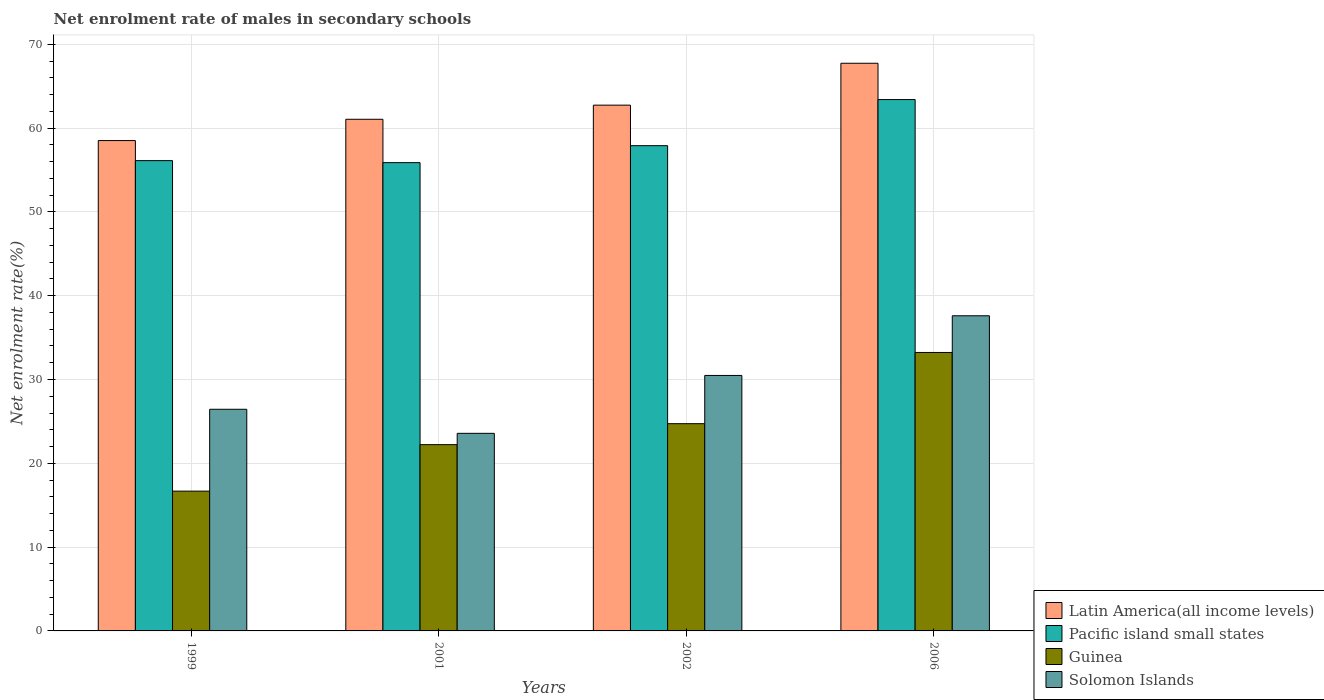How many groups of bars are there?
Offer a very short reply. 4. Are the number of bars on each tick of the X-axis equal?
Your answer should be very brief. Yes. How many bars are there on the 1st tick from the left?
Offer a terse response. 4. What is the label of the 4th group of bars from the left?
Ensure brevity in your answer.  2006. What is the net enrolment rate of males in secondary schools in Guinea in 1999?
Your answer should be very brief. 16.68. Across all years, what is the maximum net enrolment rate of males in secondary schools in Solomon Islands?
Offer a terse response. 37.61. Across all years, what is the minimum net enrolment rate of males in secondary schools in Pacific island small states?
Your response must be concise. 55.88. In which year was the net enrolment rate of males in secondary schools in Latin America(all income levels) maximum?
Your answer should be compact. 2006. In which year was the net enrolment rate of males in secondary schools in Pacific island small states minimum?
Make the answer very short. 2001. What is the total net enrolment rate of males in secondary schools in Solomon Islands in the graph?
Offer a very short reply. 118.12. What is the difference between the net enrolment rate of males in secondary schools in Pacific island small states in 2001 and that in 2002?
Offer a very short reply. -2.03. What is the difference between the net enrolment rate of males in secondary schools in Solomon Islands in 2006 and the net enrolment rate of males in secondary schools in Pacific island small states in 1999?
Provide a succinct answer. -18.51. What is the average net enrolment rate of males in secondary schools in Pacific island small states per year?
Your answer should be very brief. 58.33. In the year 2002, what is the difference between the net enrolment rate of males in secondary schools in Pacific island small states and net enrolment rate of males in secondary schools in Latin America(all income levels)?
Your response must be concise. -4.84. In how many years, is the net enrolment rate of males in secondary schools in Guinea greater than 38 %?
Provide a succinct answer. 0. What is the ratio of the net enrolment rate of males in secondary schools in Solomon Islands in 1999 to that in 2006?
Your response must be concise. 0.7. Is the difference between the net enrolment rate of males in secondary schools in Pacific island small states in 2001 and 2002 greater than the difference between the net enrolment rate of males in secondary schools in Latin America(all income levels) in 2001 and 2002?
Your response must be concise. No. What is the difference between the highest and the second highest net enrolment rate of males in secondary schools in Guinea?
Provide a short and direct response. 8.5. What is the difference between the highest and the lowest net enrolment rate of males in secondary schools in Pacific island small states?
Your answer should be very brief. 7.53. In how many years, is the net enrolment rate of males in secondary schools in Latin America(all income levels) greater than the average net enrolment rate of males in secondary schools in Latin America(all income levels) taken over all years?
Your answer should be very brief. 2. Is the sum of the net enrolment rate of males in secondary schools in Pacific island small states in 2002 and 2006 greater than the maximum net enrolment rate of males in secondary schools in Solomon Islands across all years?
Give a very brief answer. Yes. Is it the case that in every year, the sum of the net enrolment rate of males in secondary schools in Solomon Islands and net enrolment rate of males in secondary schools in Guinea is greater than the sum of net enrolment rate of males in secondary schools in Pacific island small states and net enrolment rate of males in secondary schools in Latin America(all income levels)?
Provide a short and direct response. No. What does the 4th bar from the left in 2001 represents?
Your answer should be very brief. Solomon Islands. What does the 2nd bar from the right in 2001 represents?
Provide a short and direct response. Guinea. How many bars are there?
Your response must be concise. 16. How many legend labels are there?
Offer a very short reply. 4. What is the title of the graph?
Make the answer very short. Net enrolment rate of males in secondary schools. What is the label or title of the X-axis?
Give a very brief answer. Years. What is the label or title of the Y-axis?
Your answer should be compact. Net enrolment rate(%). What is the Net enrolment rate(%) of Latin America(all income levels) in 1999?
Provide a succinct answer. 58.51. What is the Net enrolment rate(%) of Pacific island small states in 1999?
Ensure brevity in your answer.  56.12. What is the Net enrolment rate(%) in Guinea in 1999?
Offer a terse response. 16.68. What is the Net enrolment rate(%) in Solomon Islands in 1999?
Offer a very short reply. 26.45. What is the Net enrolment rate(%) of Latin America(all income levels) in 2001?
Provide a short and direct response. 61.05. What is the Net enrolment rate(%) in Pacific island small states in 2001?
Your answer should be compact. 55.88. What is the Net enrolment rate(%) in Guinea in 2001?
Make the answer very short. 22.23. What is the Net enrolment rate(%) in Solomon Islands in 2001?
Provide a succinct answer. 23.58. What is the Net enrolment rate(%) of Latin America(all income levels) in 2002?
Offer a terse response. 62.74. What is the Net enrolment rate(%) of Pacific island small states in 2002?
Give a very brief answer. 57.9. What is the Net enrolment rate(%) of Guinea in 2002?
Make the answer very short. 24.73. What is the Net enrolment rate(%) of Solomon Islands in 2002?
Provide a short and direct response. 30.48. What is the Net enrolment rate(%) of Latin America(all income levels) in 2006?
Your answer should be very brief. 67.74. What is the Net enrolment rate(%) of Pacific island small states in 2006?
Keep it short and to the point. 63.41. What is the Net enrolment rate(%) in Guinea in 2006?
Keep it short and to the point. 33.23. What is the Net enrolment rate(%) of Solomon Islands in 2006?
Ensure brevity in your answer.  37.61. Across all years, what is the maximum Net enrolment rate(%) of Latin America(all income levels)?
Ensure brevity in your answer.  67.74. Across all years, what is the maximum Net enrolment rate(%) of Pacific island small states?
Your response must be concise. 63.41. Across all years, what is the maximum Net enrolment rate(%) of Guinea?
Make the answer very short. 33.23. Across all years, what is the maximum Net enrolment rate(%) of Solomon Islands?
Make the answer very short. 37.61. Across all years, what is the minimum Net enrolment rate(%) of Latin America(all income levels)?
Ensure brevity in your answer.  58.51. Across all years, what is the minimum Net enrolment rate(%) of Pacific island small states?
Provide a succinct answer. 55.88. Across all years, what is the minimum Net enrolment rate(%) in Guinea?
Your answer should be very brief. 16.68. Across all years, what is the minimum Net enrolment rate(%) of Solomon Islands?
Your answer should be very brief. 23.58. What is the total Net enrolment rate(%) of Latin America(all income levels) in the graph?
Provide a short and direct response. 250.04. What is the total Net enrolment rate(%) of Pacific island small states in the graph?
Offer a very short reply. 233.3. What is the total Net enrolment rate(%) of Guinea in the graph?
Keep it short and to the point. 96.87. What is the total Net enrolment rate(%) of Solomon Islands in the graph?
Offer a very short reply. 118.12. What is the difference between the Net enrolment rate(%) of Latin America(all income levels) in 1999 and that in 2001?
Your answer should be very brief. -2.54. What is the difference between the Net enrolment rate(%) in Pacific island small states in 1999 and that in 2001?
Provide a succinct answer. 0.24. What is the difference between the Net enrolment rate(%) of Guinea in 1999 and that in 2001?
Provide a short and direct response. -5.55. What is the difference between the Net enrolment rate(%) in Solomon Islands in 1999 and that in 2001?
Your answer should be compact. 2.87. What is the difference between the Net enrolment rate(%) of Latin America(all income levels) in 1999 and that in 2002?
Your response must be concise. -4.23. What is the difference between the Net enrolment rate(%) of Pacific island small states in 1999 and that in 2002?
Your answer should be compact. -1.79. What is the difference between the Net enrolment rate(%) in Guinea in 1999 and that in 2002?
Offer a very short reply. -8.05. What is the difference between the Net enrolment rate(%) of Solomon Islands in 1999 and that in 2002?
Make the answer very short. -4.04. What is the difference between the Net enrolment rate(%) in Latin America(all income levels) in 1999 and that in 2006?
Offer a terse response. -9.23. What is the difference between the Net enrolment rate(%) in Pacific island small states in 1999 and that in 2006?
Keep it short and to the point. -7.29. What is the difference between the Net enrolment rate(%) in Guinea in 1999 and that in 2006?
Offer a terse response. -16.55. What is the difference between the Net enrolment rate(%) of Solomon Islands in 1999 and that in 2006?
Keep it short and to the point. -11.16. What is the difference between the Net enrolment rate(%) of Latin America(all income levels) in 2001 and that in 2002?
Ensure brevity in your answer.  -1.69. What is the difference between the Net enrolment rate(%) in Pacific island small states in 2001 and that in 2002?
Make the answer very short. -2.03. What is the difference between the Net enrolment rate(%) of Guinea in 2001 and that in 2002?
Make the answer very short. -2.5. What is the difference between the Net enrolment rate(%) of Solomon Islands in 2001 and that in 2002?
Keep it short and to the point. -6.91. What is the difference between the Net enrolment rate(%) of Latin America(all income levels) in 2001 and that in 2006?
Offer a terse response. -6.68. What is the difference between the Net enrolment rate(%) of Pacific island small states in 2001 and that in 2006?
Ensure brevity in your answer.  -7.53. What is the difference between the Net enrolment rate(%) in Guinea in 2001 and that in 2006?
Make the answer very short. -11. What is the difference between the Net enrolment rate(%) in Solomon Islands in 2001 and that in 2006?
Your answer should be compact. -14.03. What is the difference between the Net enrolment rate(%) of Latin America(all income levels) in 2002 and that in 2006?
Ensure brevity in your answer.  -5. What is the difference between the Net enrolment rate(%) in Pacific island small states in 2002 and that in 2006?
Offer a terse response. -5.5. What is the difference between the Net enrolment rate(%) in Guinea in 2002 and that in 2006?
Provide a short and direct response. -8.5. What is the difference between the Net enrolment rate(%) in Solomon Islands in 2002 and that in 2006?
Your answer should be very brief. -7.12. What is the difference between the Net enrolment rate(%) of Latin America(all income levels) in 1999 and the Net enrolment rate(%) of Pacific island small states in 2001?
Offer a very short reply. 2.63. What is the difference between the Net enrolment rate(%) of Latin America(all income levels) in 1999 and the Net enrolment rate(%) of Guinea in 2001?
Your answer should be very brief. 36.28. What is the difference between the Net enrolment rate(%) in Latin America(all income levels) in 1999 and the Net enrolment rate(%) in Solomon Islands in 2001?
Provide a short and direct response. 34.93. What is the difference between the Net enrolment rate(%) of Pacific island small states in 1999 and the Net enrolment rate(%) of Guinea in 2001?
Provide a succinct answer. 33.89. What is the difference between the Net enrolment rate(%) of Pacific island small states in 1999 and the Net enrolment rate(%) of Solomon Islands in 2001?
Ensure brevity in your answer.  32.54. What is the difference between the Net enrolment rate(%) in Guinea in 1999 and the Net enrolment rate(%) in Solomon Islands in 2001?
Your answer should be compact. -6.9. What is the difference between the Net enrolment rate(%) of Latin America(all income levels) in 1999 and the Net enrolment rate(%) of Pacific island small states in 2002?
Make the answer very short. 0.61. What is the difference between the Net enrolment rate(%) of Latin America(all income levels) in 1999 and the Net enrolment rate(%) of Guinea in 2002?
Your answer should be very brief. 33.78. What is the difference between the Net enrolment rate(%) in Latin America(all income levels) in 1999 and the Net enrolment rate(%) in Solomon Islands in 2002?
Offer a very short reply. 28.03. What is the difference between the Net enrolment rate(%) in Pacific island small states in 1999 and the Net enrolment rate(%) in Guinea in 2002?
Provide a short and direct response. 31.39. What is the difference between the Net enrolment rate(%) of Pacific island small states in 1999 and the Net enrolment rate(%) of Solomon Islands in 2002?
Keep it short and to the point. 25.63. What is the difference between the Net enrolment rate(%) of Guinea in 1999 and the Net enrolment rate(%) of Solomon Islands in 2002?
Provide a succinct answer. -13.8. What is the difference between the Net enrolment rate(%) in Latin America(all income levels) in 1999 and the Net enrolment rate(%) in Pacific island small states in 2006?
Your answer should be very brief. -4.89. What is the difference between the Net enrolment rate(%) of Latin America(all income levels) in 1999 and the Net enrolment rate(%) of Guinea in 2006?
Offer a very short reply. 25.28. What is the difference between the Net enrolment rate(%) of Latin America(all income levels) in 1999 and the Net enrolment rate(%) of Solomon Islands in 2006?
Ensure brevity in your answer.  20.91. What is the difference between the Net enrolment rate(%) of Pacific island small states in 1999 and the Net enrolment rate(%) of Guinea in 2006?
Your answer should be very brief. 22.89. What is the difference between the Net enrolment rate(%) in Pacific island small states in 1999 and the Net enrolment rate(%) in Solomon Islands in 2006?
Give a very brief answer. 18.51. What is the difference between the Net enrolment rate(%) of Guinea in 1999 and the Net enrolment rate(%) of Solomon Islands in 2006?
Offer a very short reply. -20.92. What is the difference between the Net enrolment rate(%) of Latin America(all income levels) in 2001 and the Net enrolment rate(%) of Pacific island small states in 2002?
Keep it short and to the point. 3.15. What is the difference between the Net enrolment rate(%) of Latin America(all income levels) in 2001 and the Net enrolment rate(%) of Guinea in 2002?
Provide a short and direct response. 36.32. What is the difference between the Net enrolment rate(%) of Latin America(all income levels) in 2001 and the Net enrolment rate(%) of Solomon Islands in 2002?
Keep it short and to the point. 30.57. What is the difference between the Net enrolment rate(%) in Pacific island small states in 2001 and the Net enrolment rate(%) in Guinea in 2002?
Provide a succinct answer. 31.15. What is the difference between the Net enrolment rate(%) in Pacific island small states in 2001 and the Net enrolment rate(%) in Solomon Islands in 2002?
Your answer should be very brief. 25.39. What is the difference between the Net enrolment rate(%) of Guinea in 2001 and the Net enrolment rate(%) of Solomon Islands in 2002?
Your answer should be very brief. -8.26. What is the difference between the Net enrolment rate(%) of Latin America(all income levels) in 2001 and the Net enrolment rate(%) of Pacific island small states in 2006?
Offer a terse response. -2.35. What is the difference between the Net enrolment rate(%) of Latin America(all income levels) in 2001 and the Net enrolment rate(%) of Guinea in 2006?
Your answer should be compact. 27.82. What is the difference between the Net enrolment rate(%) of Latin America(all income levels) in 2001 and the Net enrolment rate(%) of Solomon Islands in 2006?
Your answer should be compact. 23.45. What is the difference between the Net enrolment rate(%) of Pacific island small states in 2001 and the Net enrolment rate(%) of Guinea in 2006?
Ensure brevity in your answer.  22.65. What is the difference between the Net enrolment rate(%) in Pacific island small states in 2001 and the Net enrolment rate(%) in Solomon Islands in 2006?
Ensure brevity in your answer.  18.27. What is the difference between the Net enrolment rate(%) in Guinea in 2001 and the Net enrolment rate(%) in Solomon Islands in 2006?
Keep it short and to the point. -15.38. What is the difference between the Net enrolment rate(%) in Latin America(all income levels) in 2002 and the Net enrolment rate(%) in Pacific island small states in 2006?
Keep it short and to the point. -0.67. What is the difference between the Net enrolment rate(%) of Latin America(all income levels) in 2002 and the Net enrolment rate(%) of Guinea in 2006?
Your response must be concise. 29.51. What is the difference between the Net enrolment rate(%) of Latin America(all income levels) in 2002 and the Net enrolment rate(%) of Solomon Islands in 2006?
Your answer should be compact. 25.13. What is the difference between the Net enrolment rate(%) of Pacific island small states in 2002 and the Net enrolment rate(%) of Guinea in 2006?
Ensure brevity in your answer.  24.67. What is the difference between the Net enrolment rate(%) in Pacific island small states in 2002 and the Net enrolment rate(%) in Solomon Islands in 2006?
Offer a terse response. 20.3. What is the difference between the Net enrolment rate(%) in Guinea in 2002 and the Net enrolment rate(%) in Solomon Islands in 2006?
Provide a short and direct response. -12.88. What is the average Net enrolment rate(%) of Latin America(all income levels) per year?
Make the answer very short. 62.51. What is the average Net enrolment rate(%) in Pacific island small states per year?
Your response must be concise. 58.33. What is the average Net enrolment rate(%) of Guinea per year?
Your response must be concise. 24.22. What is the average Net enrolment rate(%) of Solomon Islands per year?
Your answer should be very brief. 29.53. In the year 1999, what is the difference between the Net enrolment rate(%) of Latin America(all income levels) and Net enrolment rate(%) of Pacific island small states?
Your response must be concise. 2.39. In the year 1999, what is the difference between the Net enrolment rate(%) of Latin America(all income levels) and Net enrolment rate(%) of Guinea?
Make the answer very short. 41.83. In the year 1999, what is the difference between the Net enrolment rate(%) of Latin America(all income levels) and Net enrolment rate(%) of Solomon Islands?
Your response must be concise. 32.06. In the year 1999, what is the difference between the Net enrolment rate(%) of Pacific island small states and Net enrolment rate(%) of Guinea?
Provide a short and direct response. 39.44. In the year 1999, what is the difference between the Net enrolment rate(%) in Pacific island small states and Net enrolment rate(%) in Solomon Islands?
Your answer should be very brief. 29.67. In the year 1999, what is the difference between the Net enrolment rate(%) of Guinea and Net enrolment rate(%) of Solomon Islands?
Your response must be concise. -9.77. In the year 2001, what is the difference between the Net enrolment rate(%) in Latin America(all income levels) and Net enrolment rate(%) in Pacific island small states?
Keep it short and to the point. 5.18. In the year 2001, what is the difference between the Net enrolment rate(%) of Latin America(all income levels) and Net enrolment rate(%) of Guinea?
Provide a short and direct response. 38.83. In the year 2001, what is the difference between the Net enrolment rate(%) of Latin America(all income levels) and Net enrolment rate(%) of Solomon Islands?
Give a very brief answer. 37.47. In the year 2001, what is the difference between the Net enrolment rate(%) in Pacific island small states and Net enrolment rate(%) in Guinea?
Your answer should be compact. 33.65. In the year 2001, what is the difference between the Net enrolment rate(%) in Pacific island small states and Net enrolment rate(%) in Solomon Islands?
Offer a terse response. 32.3. In the year 2001, what is the difference between the Net enrolment rate(%) of Guinea and Net enrolment rate(%) of Solomon Islands?
Provide a short and direct response. -1.35. In the year 2002, what is the difference between the Net enrolment rate(%) of Latin America(all income levels) and Net enrolment rate(%) of Pacific island small states?
Your answer should be compact. 4.84. In the year 2002, what is the difference between the Net enrolment rate(%) in Latin America(all income levels) and Net enrolment rate(%) in Guinea?
Make the answer very short. 38.01. In the year 2002, what is the difference between the Net enrolment rate(%) in Latin America(all income levels) and Net enrolment rate(%) in Solomon Islands?
Your answer should be very brief. 32.25. In the year 2002, what is the difference between the Net enrolment rate(%) of Pacific island small states and Net enrolment rate(%) of Guinea?
Provide a succinct answer. 33.17. In the year 2002, what is the difference between the Net enrolment rate(%) of Pacific island small states and Net enrolment rate(%) of Solomon Islands?
Make the answer very short. 27.42. In the year 2002, what is the difference between the Net enrolment rate(%) of Guinea and Net enrolment rate(%) of Solomon Islands?
Provide a short and direct response. -5.75. In the year 2006, what is the difference between the Net enrolment rate(%) of Latin America(all income levels) and Net enrolment rate(%) of Pacific island small states?
Give a very brief answer. 4.33. In the year 2006, what is the difference between the Net enrolment rate(%) in Latin America(all income levels) and Net enrolment rate(%) in Guinea?
Provide a short and direct response. 34.51. In the year 2006, what is the difference between the Net enrolment rate(%) in Latin America(all income levels) and Net enrolment rate(%) in Solomon Islands?
Offer a terse response. 30.13. In the year 2006, what is the difference between the Net enrolment rate(%) of Pacific island small states and Net enrolment rate(%) of Guinea?
Your response must be concise. 30.18. In the year 2006, what is the difference between the Net enrolment rate(%) of Pacific island small states and Net enrolment rate(%) of Solomon Islands?
Make the answer very short. 25.8. In the year 2006, what is the difference between the Net enrolment rate(%) in Guinea and Net enrolment rate(%) in Solomon Islands?
Your answer should be compact. -4.38. What is the ratio of the Net enrolment rate(%) in Latin America(all income levels) in 1999 to that in 2001?
Ensure brevity in your answer.  0.96. What is the ratio of the Net enrolment rate(%) of Guinea in 1999 to that in 2001?
Give a very brief answer. 0.75. What is the ratio of the Net enrolment rate(%) in Solomon Islands in 1999 to that in 2001?
Make the answer very short. 1.12. What is the ratio of the Net enrolment rate(%) of Latin America(all income levels) in 1999 to that in 2002?
Your response must be concise. 0.93. What is the ratio of the Net enrolment rate(%) of Pacific island small states in 1999 to that in 2002?
Make the answer very short. 0.97. What is the ratio of the Net enrolment rate(%) in Guinea in 1999 to that in 2002?
Ensure brevity in your answer.  0.67. What is the ratio of the Net enrolment rate(%) of Solomon Islands in 1999 to that in 2002?
Your answer should be compact. 0.87. What is the ratio of the Net enrolment rate(%) in Latin America(all income levels) in 1999 to that in 2006?
Your answer should be compact. 0.86. What is the ratio of the Net enrolment rate(%) in Pacific island small states in 1999 to that in 2006?
Your response must be concise. 0.89. What is the ratio of the Net enrolment rate(%) in Guinea in 1999 to that in 2006?
Your answer should be very brief. 0.5. What is the ratio of the Net enrolment rate(%) in Solomon Islands in 1999 to that in 2006?
Your answer should be compact. 0.7. What is the ratio of the Net enrolment rate(%) of Latin America(all income levels) in 2001 to that in 2002?
Give a very brief answer. 0.97. What is the ratio of the Net enrolment rate(%) in Pacific island small states in 2001 to that in 2002?
Your answer should be very brief. 0.96. What is the ratio of the Net enrolment rate(%) in Guinea in 2001 to that in 2002?
Provide a succinct answer. 0.9. What is the ratio of the Net enrolment rate(%) in Solomon Islands in 2001 to that in 2002?
Provide a succinct answer. 0.77. What is the ratio of the Net enrolment rate(%) of Latin America(all income levels) in 2001 to that in 2006?
Your response must be concise. 0.9. What is the ratio of the Net enrolment rate(%) of Pacific island small states in 2001 to that in 2006?
Your answer should be compact. 0.88. What is the ratio of the Net enrolment rate(%) in Guinea in 2001 to that in 2006?
Your answer should be very brief. 0.67. What is the ratio of the Net enrolment rate(%) in Solomon Islands in 2001 to that in 2006?
Keep it short and to the point. 0.63. What is the ratio of the Net enrolment rate(%) of Latin America(all income levels) in 2002 to that in 2006?
Give a very brief answer. 0.93. What is the ratio of the Net enrolment rate(%) in Pacific island small states in 2002 to that in 2006?
Your response must be concise. 0.91. What is the ratio of the Net enrolment rate(%) in Guinea in 2002 to that in 2006?
Keep it short and to the point. 0.74. What is the ratio of the Net enrolment rate(%) in Solomon Islands in 2002 to that in 2006?
Your response must be concise. 0.81. What is the difference between the highest and the second highest Net enrolment rate(%) of Latin America(all income levels)?
Provide a succinct answer. 5. What is the difference between the highest and the second highest Net enrolment rate(%) of Pacific island small states?
Your response must be concise. 5.5. What is the difference between the highest and the second highest Net enrolment rate(%) of Guinea?
Your answer should be compact. 8.5. What is the difference between the highest and the second highest Net enrolment rate(%) in Solomon Islands?
Your response must be concise. 7.12. What is the difference between the highest and the lowest Net enrolment rate(%) in Latin America(all income levels)?
Your response must be concise. 9.23. What is the difference between the highest and the lowest Net enrolment rate(%) of Pacific island small states?
Offer a terse response. 7.53. What is the difference between the highest and the lowest Net enrolment rate(%) in Guinea?
Your answer should be compact. 16.55. What is the difference between the highest and the lowest Net enrolment rate(%) of Solomon Islands?
Offer a very short reply. 14.03. 